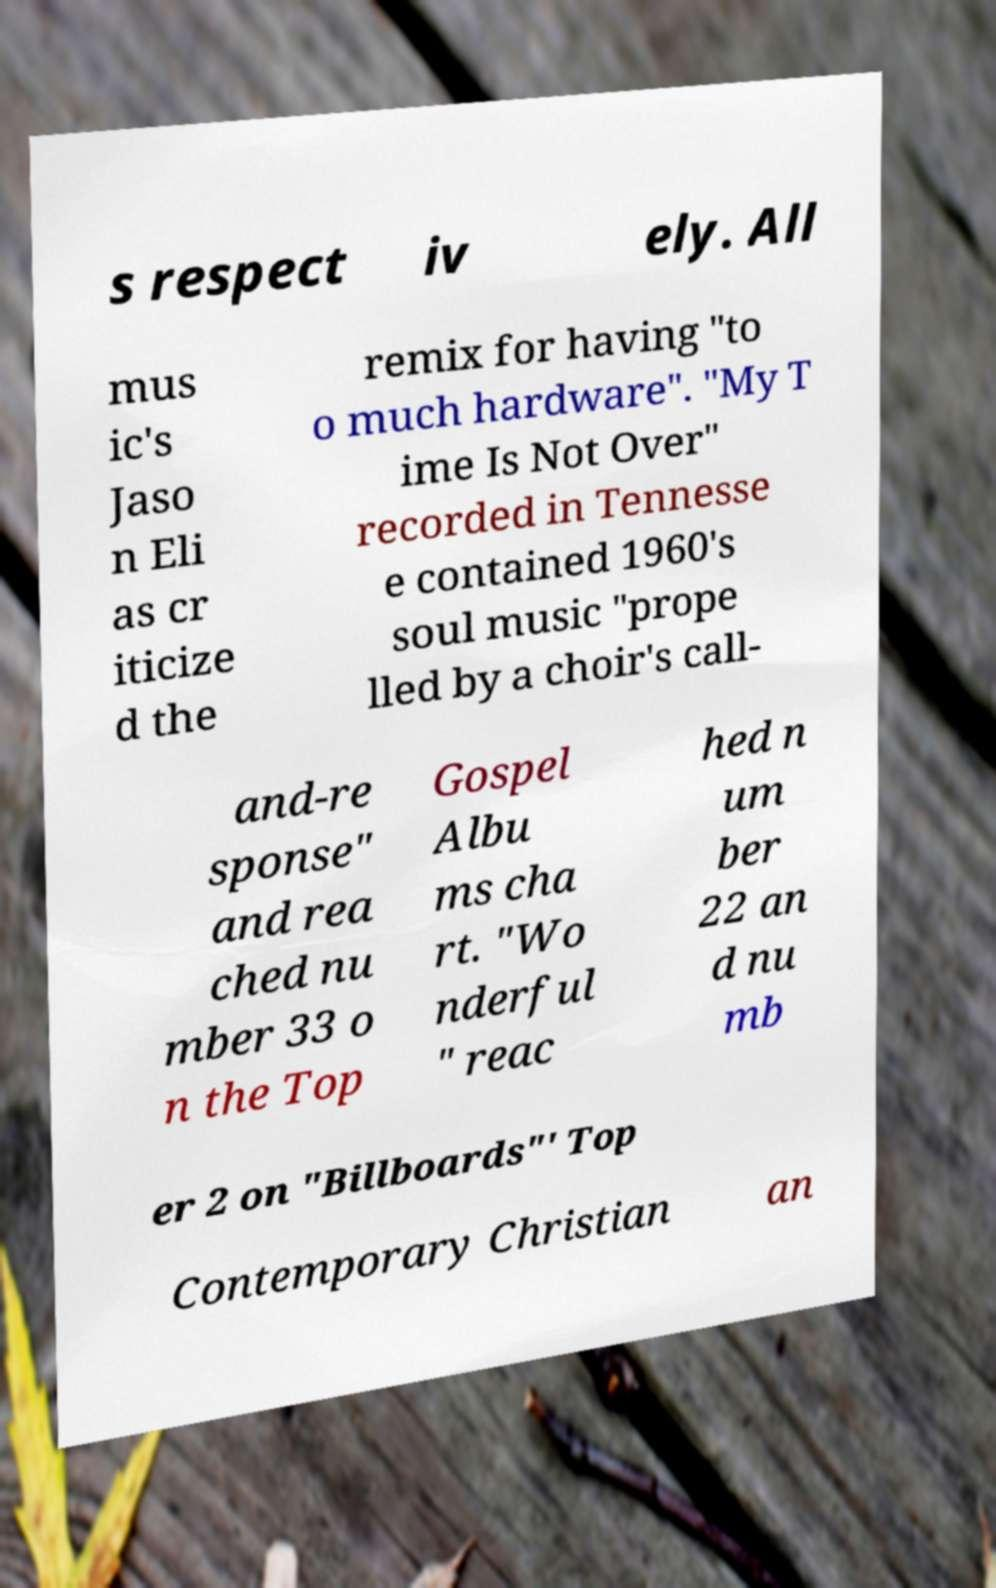Can you accurately transcribe the text from the provided image for me? s respect iv ely. All mus ic's Jaso n Eli as cr iticize d the remix for having "to o much hardware". "My T ime Is Not Over" recorded in Tennesse e contained 1960's soul music "prope lled by a choir's call- and-re sponse" and rea ched nu mber 33 o n the Top Gospel Albu ms cha rt. "Wo nderful " reac hed n um ber 22 an d nu mb er 2 on "Billboards"' Top Contemporary Christian an 